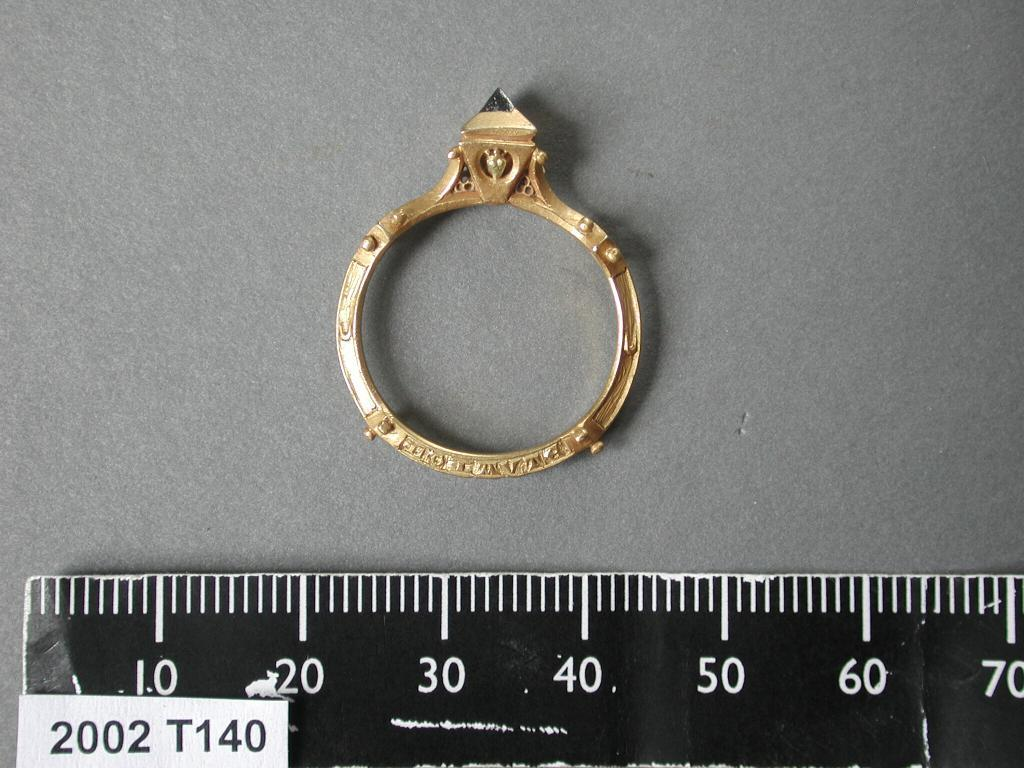Provide a one-sentence caption for the provided image. A ring with a gem on it is rested next to a ruler measuring it's size. 